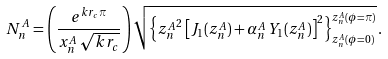Convert formula to latex. <formula><loc_0><loc_0><loc_500><loc_500>N _ { n } ^ { A } = \left ( \frac { e ^ { k r _ { c } \pi } } { x _ { n } ^ { A } \, \sqrt { k r _ { c } } } \right ) \sqrt { \left \{ { z _ { n } ^ { A } } ^ { 2 } \left [ J _ { 1 } ( z _ { n } ^ { A } ) + \alpha _ { n } ^ { A } \, Y _ { 1 } ( z _ { n } ^ { A } ) \right ] ^ { 2 } \right \} ^ { z _ { n } ^ { A } ( \phi = \pi ) } _ { z _ { n } ^ { A } ( \phi = 0 ) } } \, .</formula> 